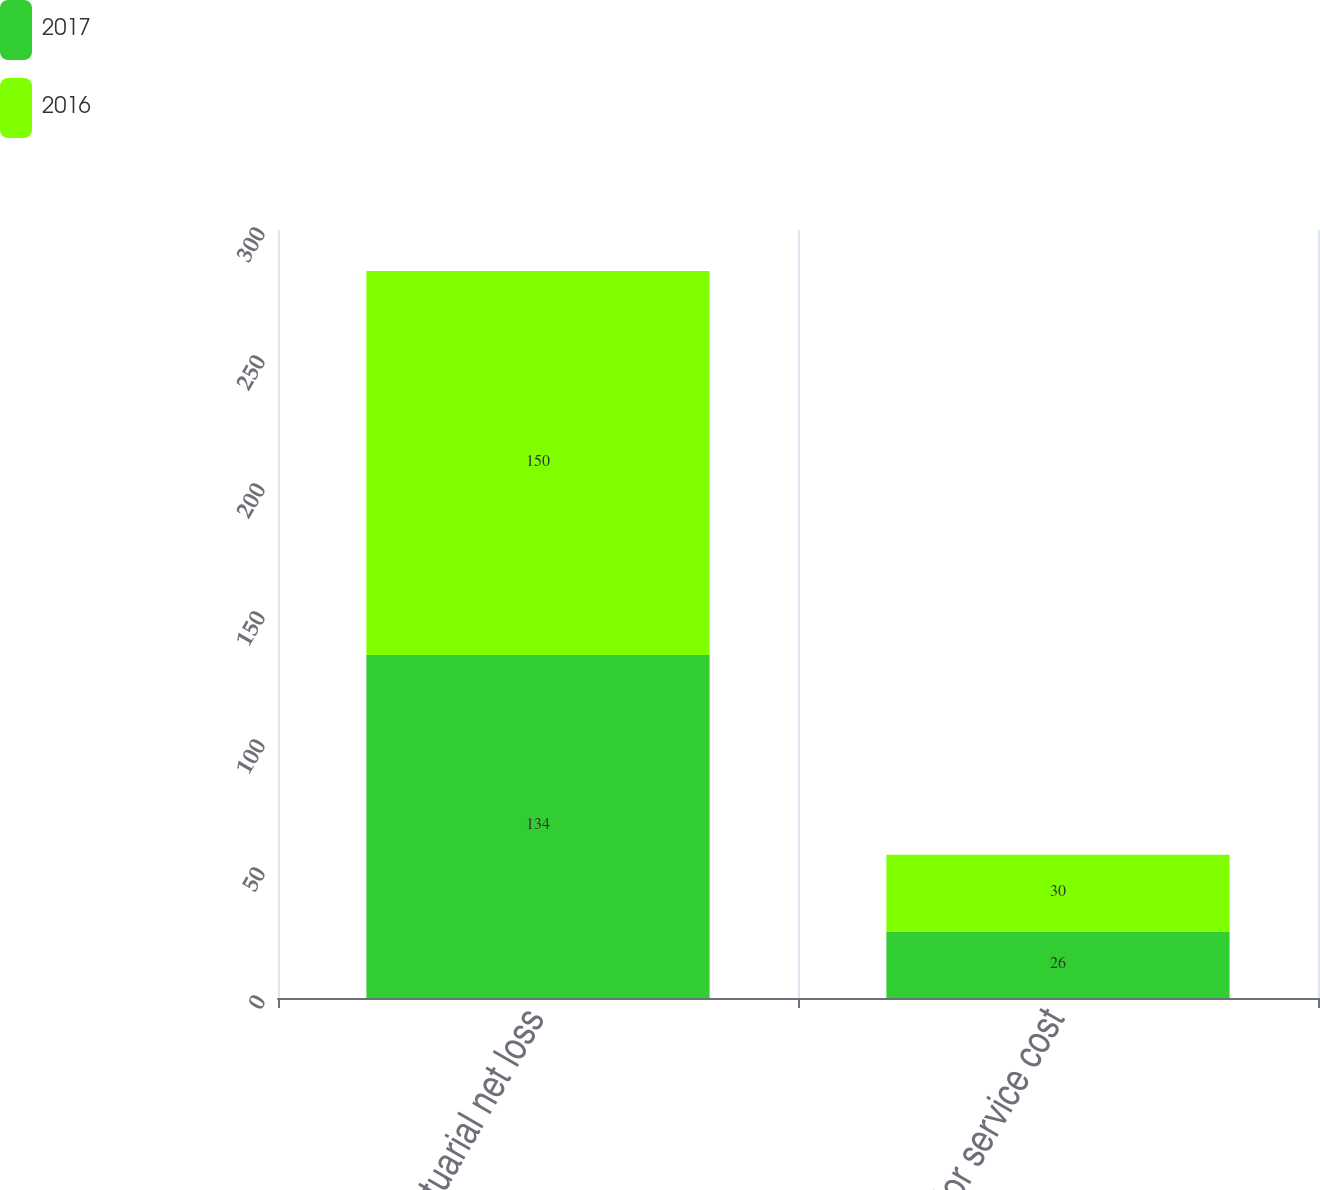Convert chart to OTSL. <chart><loc_0><loc_0><loc_500><loc_500><stacked_bar_chart><ecel><fcel>Actuarial net loss<fcel>Prior service cost<nl><fcel>2017<fcel>134<fcel>26<nl><fcel>2016<fcel>150<fcel>30<nl></chart> 